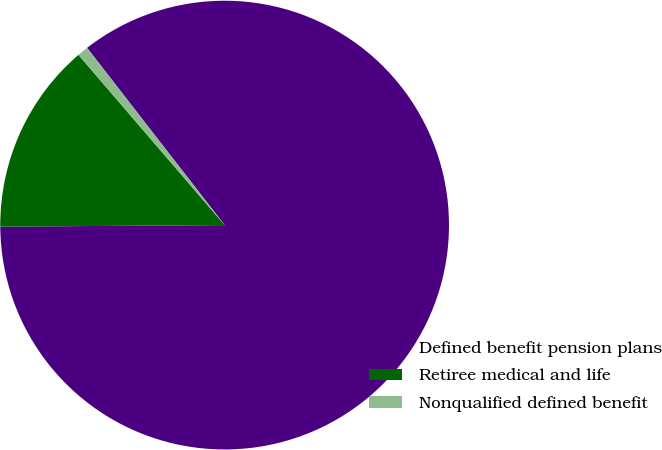Convert chart. <chart><loc_0><loc_0><loc_500><loc_500><pie_chart><fcel>Defined benefit pension plans<fcel>Retiree medical and life<fcel>Nonqualified defined benefit<nl><fcel>85.4%<fcel>13.82%<fcel>0.79%<nl></chart> 